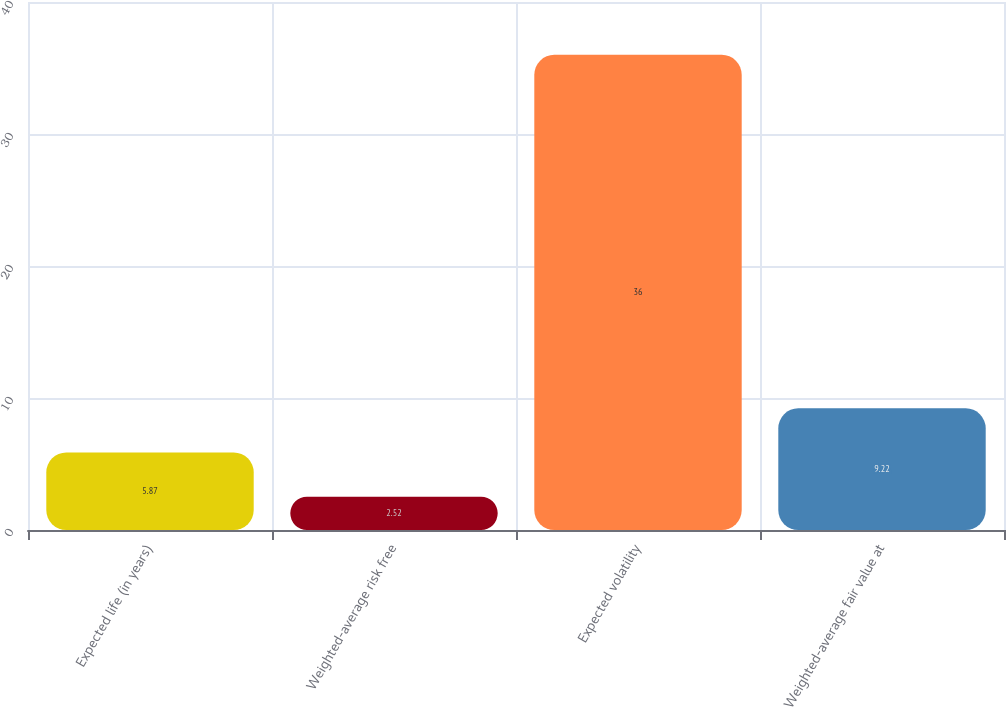Convert chart to OTSL. <chart><loc_0><loc_0><loc_500><loc_500><bar_chart><fcel>Expected life (in years)<fcel>Weighted-average risk free<fcel>Expected volatility<fcel>Weighted-average fair value at<nl><fcel>5.87<fcel>2.52<fcel>36<fcel>9.22<nl></chart> 